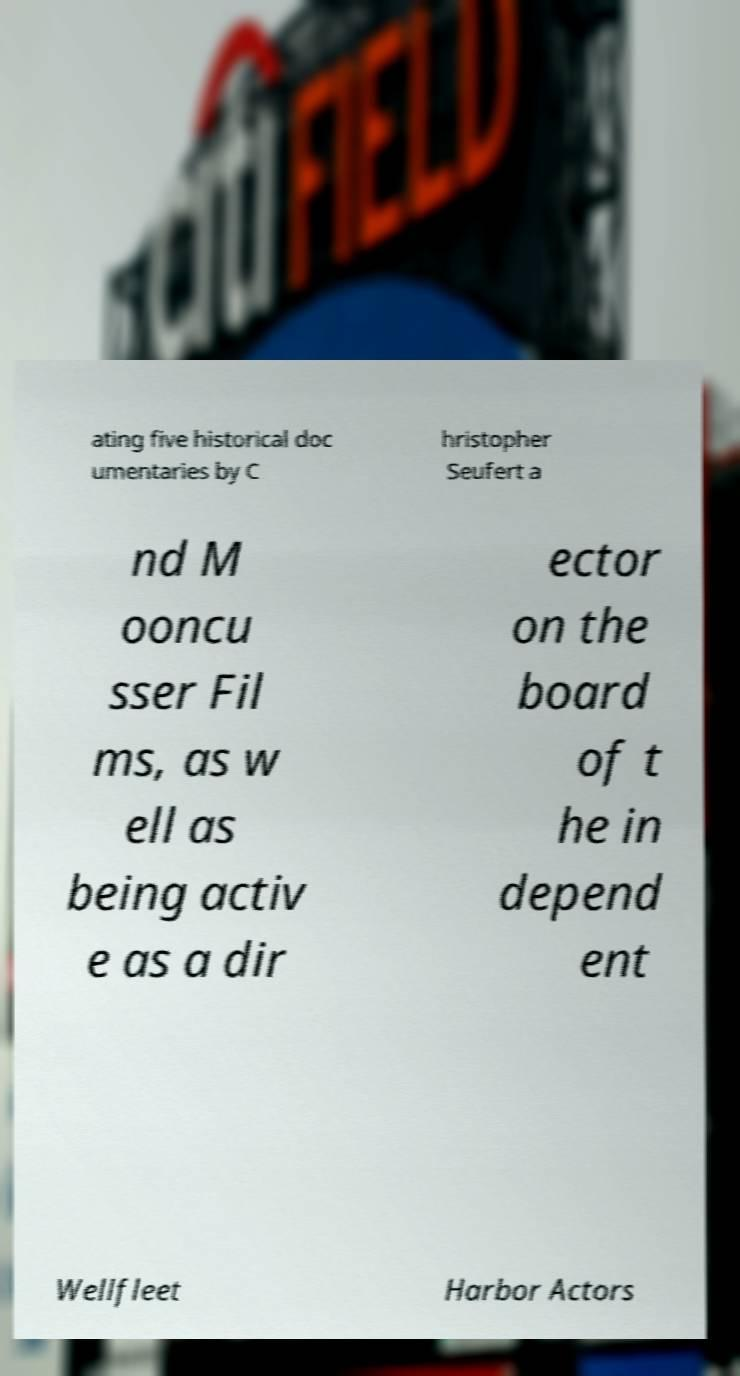What messages or text are displayed in this image? I need them in a readable, typed format. ating five historical doc umentaries by C hristopher Seufert a nd M ooncu sser Fil ms, as w ell as being activ e as a dir ector on the board of t he in depend ent Wellfleet Harbor Actors 